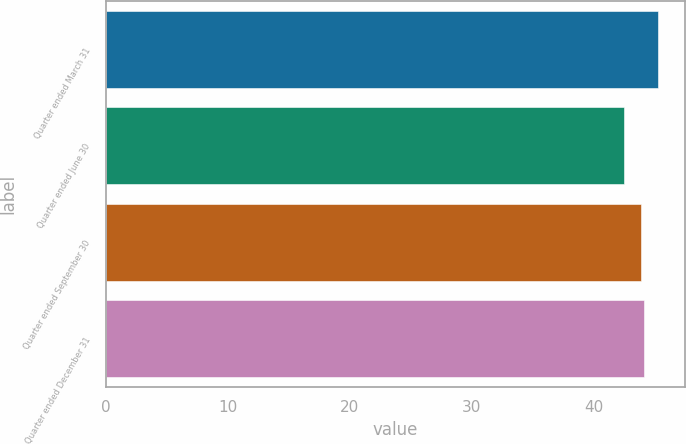Convert chart to OTSL. <chart><loc_0><loc_0><loc_500><loc_500><bar_chart><fcel>Quarter ended March 31<fcel>Quarter ended June 30<fcel>Quarter ended September 30<fcel>Quarter ended December 31<nl><fcel>45.2<fcel>42.45<fcel>43.8<fcel>44.07<nl></chart> 